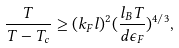Convert formula to latex. <formula><loc_0><loc_0><loc_500><loc_500>\frac { T } { T - T _ { c } } \geq ( k _ { F } l ) ^ { 2 } ( \frac { l _ { B } T } { d \epsilon _ { F } } ) ^ { 4 / 3 } ,</formula> 